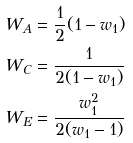Convert formula to latex. <formula><loc_0><loc_0><loc_500><loc_500>W _ { A } & = \frac { 1 } { 2 } ( 1 - w _ { 1 } ) \\ W _ { C } & = \frac { 1 } { 2 ( 1 - w _ { 1 } ) } \\ W _ { E } & = \frac { w _ { 1 } ^ { 2 } } { 2 ( w _ { 1 } - 1 ) }</formula> 